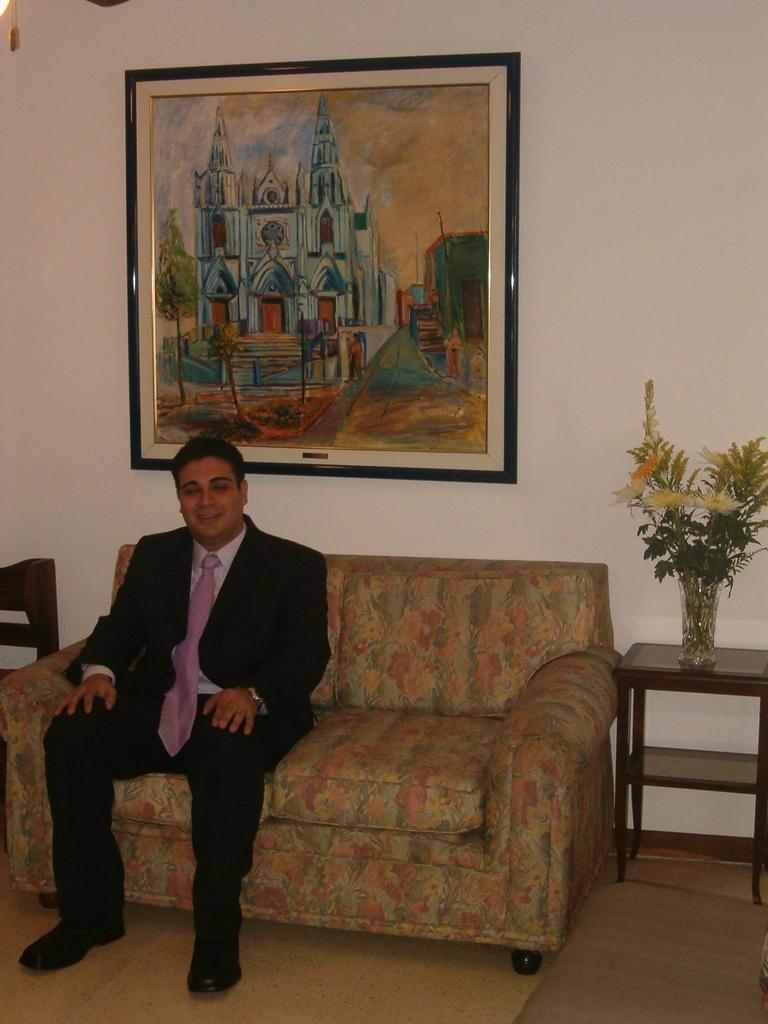In one or two sentences, can you explain what this image depicts? In this picture we can see man wore blazer, tie and smiling and sitting on sofa beside to him there is table and on table we can see flower vase and in background we can see wall with frames. 